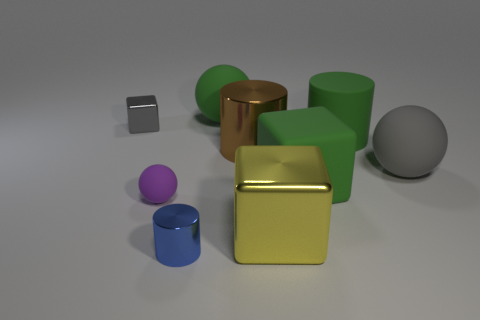Subtract all big matte spheres. How many spheres are left? 1 Subtract all yellow cubes. How many cubes are left? 2 Add 1 gray metal things. How many objects exist? 10 Subtract 1 cylinders. How many cylinders are left? 2 Subtract 0 red cubes. How many objects are left? 9 Subtract all spheres. How many objects are left? 6 Subtract all red balls. Subtract all blue cylinders. How many balls are left? 3 Subtract all blue cylinders. How many purple balls are left? 1 Subtract all purple objects. Subtract all gray metal blocks. How many objects are left? 7 Add 7 large yellow metal blocks. How many large yellow metal blocks are left? 8 